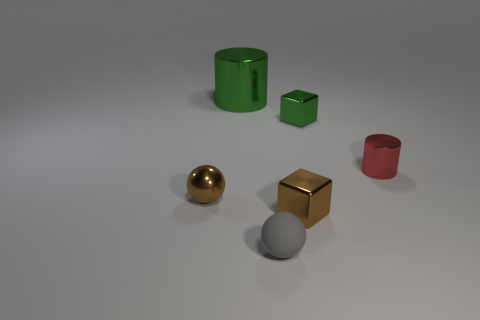Add 2 brown metallic blocks. How many objects exist? 8 Subtract 1 blocks. How many blocks are left? 1 Subtract all cubes. How many objects are left? 4 Subtract all red cylinders. How many cylinders are left? 1 Add 6 green cylinders. How many green cylinders are left? 7 Add 5 green metal things. How many green metal things exist? 7 Subtract 0 purple cylinders. How many objects are left? 6 Subtract all cyan blocks. Subtract all brown cylinders. How many blocks are left? 2 Subtract all gray metallic cylinders. Subtract all tiny cylinders. How many objects are left? 5 